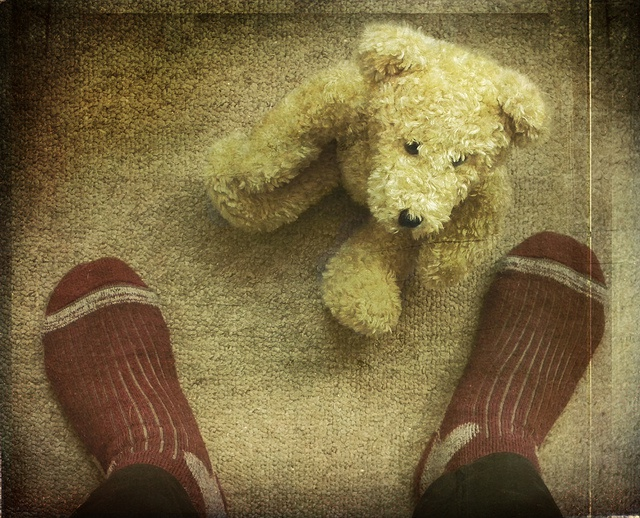Describe the objects in this image and their specific colors. I can see people in olive, maroon, black, and gray tones and teddy bear in olive and khaki tones in this image. 